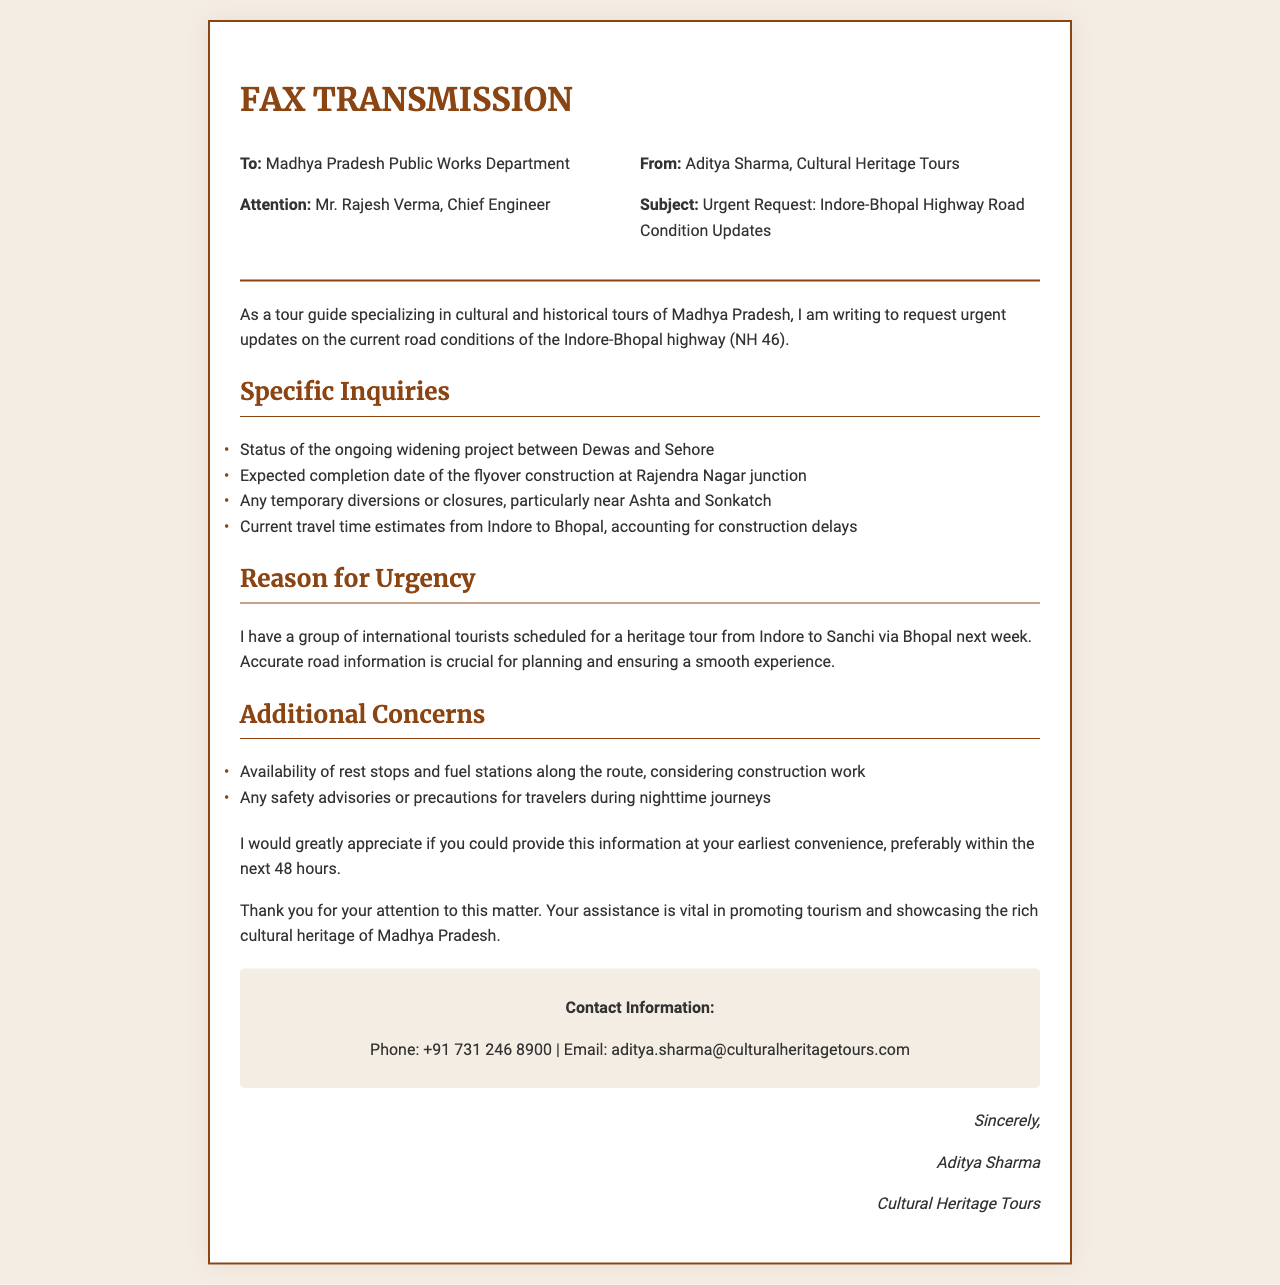What is the subject of the fax? The subject is clearly stated in the fax as "Urgent Request: Indore-Bhopal Highway Road Condition Updates."
Answer: Urgent Request: Indore-Bhopal Highway Road Condition Updates Who is the recipient of the fax? The fax is addressed to the "Madhya Pradesh Public Works Department."
Answer: Madhya Pradesh Public Works Department What is the name of the sender? The sender identifies themselves as "Aditya Sharma."
Answer: Aditya Sharma What specific project status is requested in the inquiries? The status of the ongoing "widening project between Dewas and Sehore" is requested.
Answer: widening project between Dewas and Sehore What is the expected completion milestone mentioned in the fax? The expected completion date of the "flyover construction at Rajendra Nagar junction" is sought.
Answer: flyover construction at Rajendra Nagar junction What additional concern is raised regarding traveler safety? The fax mentions "safety advisories or precautions for travelers during nighttime journeys."
Answer: safety advisories or precautions for travelers during nighttime journeys What is the urgency for the information request? The sender has a group of "international tourists scheduled for a heritage tour."
Answer: international tourists scheduled for a heritage tour What is the timeline for the requested information? The sender requests the information to be provided "preferably within the next 48 hours."
Answer: preferably within the next 48 hours What contact method is provided by the sender? The sender provides an email address for contact: "aditya.sharma@culturalheritagetours.com."
Answer: aditya.sharma@culturalheritagetours.com 